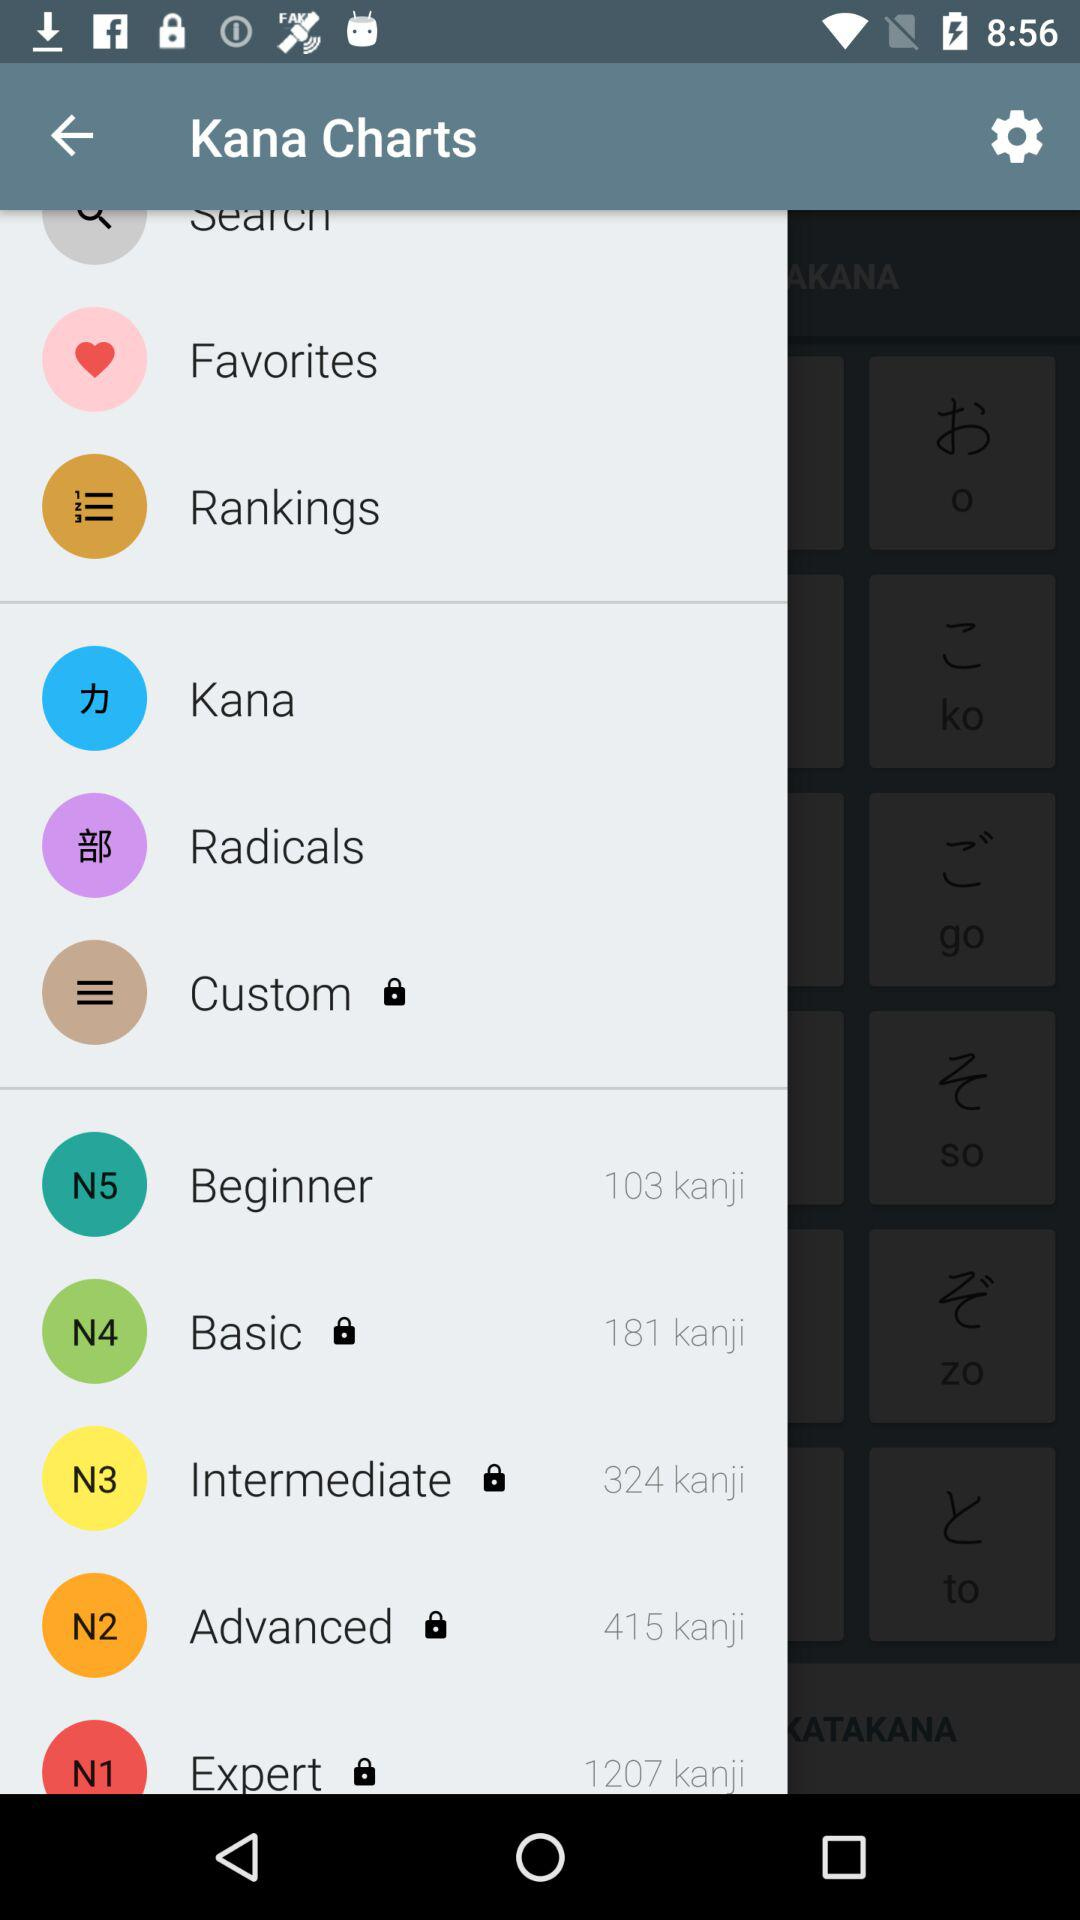How many kanji are there in "Basic"? There are 181 kanji in "Basic". 